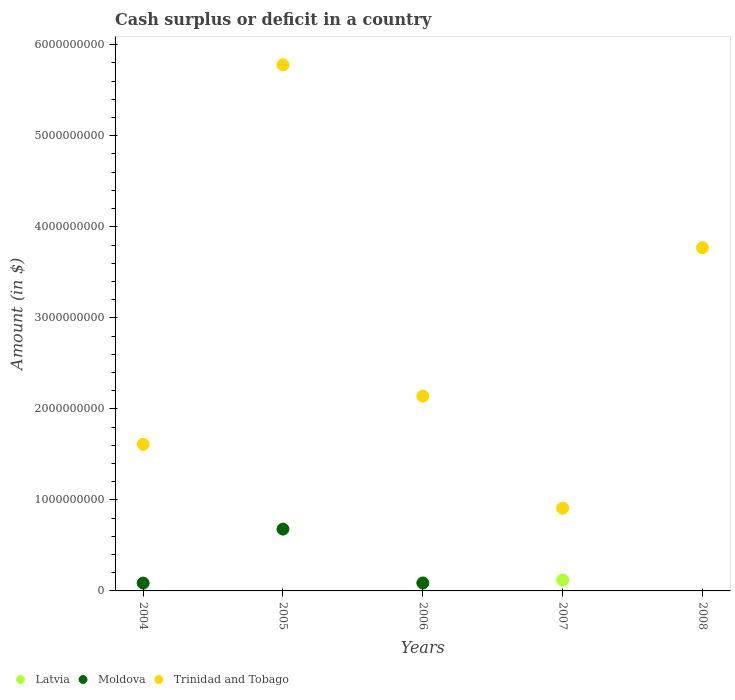How many different coloured dotlines are there?
Provide a succinct answer. 3. Is the number of dotlines equal to the number of legend labels?
Your response must be concise. No. Across all years, what is the maximum amount of cash surplus or deficit in Trinidad and Tobago?
Offer a very short reply. 5.78e+09. What is the total amount of cash surplus or deficit in Moldova in the graph?
Keep it short and to the point. 8.53e+08. What is the difference between the amount of cash surplus or deficit in Trinidad and Tobago in 2005 and that in 2007?
Provide a succinct answer. 4.87e+09. What is the difference between the amount of cash surplus or deficit in Latvia in 2004 and the amount of cash surplus or deficit in Trinidad and Tobago in 2005?
Make the answer very short. -5.78e+09. What is the average amount of cash surplus or deficit in Moldova per year?
Your answer should be very brief. 1.71e+08. In the year 2005, what is the difference between the amount of cash surplus or deficit in Trinidad and Tobago and amount of cash surplus or deficit in Moldova?
Make the answer very short. 5.10e+09. What is the ratio of the amount of cash surplus or deficit in Moldova in 2005 to that in 2006?
Provide a short and direct response. 7.76. Is the difference between the amount of cash surplus or deficit in Trinidad and Tobago in 2004 and 2005 greater than the difference between the amount of cash surplus or deficit in Moldova in 2004 and 2005?
Ensure brevity in your answer.  No. What is the difference between the highest and the second highest amount of cash surplus or deficit in Moldova?
Your answer should be compact. 5.92e+08. What is the difference between the highest and the lowest amount of cash surplus or deficit in Latvia?
Provide a short and direct response. 1.19e+08. In how many years, is the amount of cash surplus or deficit in Trinidad and Tobago greater than the average amount of cash surplus or deficit in Trinidad and Tobago taken over all years?
Give a very brief answer. 2. Is it the case that in every year, the sum of the amount of cash surplus or deficit in Trinidad and Tobago and amount of cash surplus or deficit in Moldova  is greater than the amount of cash surplus or deficit in Latvia?
Make the answer very short. Yes. Is the amount of cash surplus or deficit in Moldova strictly less than the amount of cash surplus or deficit in Latvia over the years?
Make the answer very short. No. How many dotlines are there?
Offer a very short reply. 3. Are the values on the major ticks of Y-axis written in scientific E-notation?
Provide a succinct answer. No. Where does the legend appear in the graph?
Make the answer very short. Bottom left. What is the title of the graph?
Your answer should be very brief. Cash surplus or deficit in a country. Does "Lesotho" appear as one of the legend labels in the graph?
Ensure brevity in your answer.  No. What is the label or title of the Y-axis?
Provide a succinct answer. Amount (in $). What is the Amount (in $) of Moldova in 2004?
Provide a short and direct response. 8.61e+07. What is the Amount (in $) in Trinidad and Tobago in 2004?
Ensure brevity in your answer.  1.61e+09. What is the Amount (in $) in Moldova in 2005?
Your answer should be very brief. 6.79e+08. What is the Amount (in $) of Trinidad and Tobago in 2005?
Keep it short and to the point. 5.78e+09. What is the Amount (in $) of Moldova in 2006?
Provide a succinct answer. 8.75e+07. What is the Amount (in $) in Trinidad and Tobago in 2006?
Your response must be concise. 2.14e+09. What is the Amount (in $) in Latvia in 2007?
Provide a short and direct response. 1.19e+08. What is the Amount (in $) of Moldova in 2007?
Keep it short and to the point. 0. What is the Amount (in $) in Trinidad and Tobago in 2007?
Your answer should be compact. 9.09e+08. What is the Amount (in $) of Moldova in 2008?
Your answer should be very brief. 0. What is the Amount (in $) of Trinidad and Tobago in 2008?
Make the answer very short. 3.77e+09. Across all years, what is the maximum Amount (in $) of Latvia?
Ensure brevity in your answer.  1.19e+08. Across all years, what is the maximum Amount (in $) in Moldova?
Make the answer very short. 6.79e+08. Across all years, what is the maximum Amount (in $) of Trinidad and Tobago?
Give a very brief answer. 5.78e+09. Across all years, what is the minimum Amount (in $) in Latvia?
Offer a terse response. 0. Across all years, what is the minimum Amount (in $) in Moldova?
Offer a very short reply. 0. Across all years, what is the minimum Amount (in $) in Trinidad and Tobago?
Offer a very short reply. 9.09e+08. What is the total Amount (in $) of Latvia in the graph?
Provide a short and direct response. 1.19e+08. What is the total Amount (in $) of Moldova in the graph?
Ensure brevity in your answer.  8.53e+08. What is the total Amount (in $) of Trinidad and Tobago in the graph?
Provide a short and direct response. 1.42e+1. What is the difference between the Amount (in $) of Moldova in 2004 and that in 2005?
Offer a terse response. -5.93e+08. What is the difference between the Amount (in $) of Trinidad and Tobago in 2004 and that in 2005?
Your response must be concise. -4.17e+09. What is the difference between the Amount (in $) of Moldova in 2004 and that in 2006?
Provide a short and direct response. -1.40e+06. What is the difference between the Amount (in $) of Trinidad and Tobago in 2004 and that in 2006?
Offer a terse response. -5.30e+08. What is the difference between the Amount (in $) of Trinidad and Tobago in 2004 and that in 2007?
Give a very brief answer. 7.01e+08. What is the difference between the Amount (in $) in Trinidad and Tobago in 2004 and that in 2008?
Your response must be concise. -2.16e+09. What is the difference between the Amount (in $) in Moldova in 2005 and that in 2006?
Give a very brief answer. 5.92e+08. What is the difference between the Amount (in $) in Trinidad and Tobago in 2005 and that in 2006?
Give a very brief answer. 3.64e+09. What is the difference between the Amount (in $) of Trinidad and Tobago in 2005 and that in 2007?
Your response must be concise. 4.87e+09. What is the difference between the Amount (in $) of Trinidad and Tobago in 2005 and that in 2008?
Offer a very short reply. 2.01e+09. What is the difference between the Amount (in $) of Trinidad and Tobago in 2006 and that in 2007?
Provide a succinct answer. 1.23e+09. What is the difference between the Amount (in $) in Trinidad and Tobago in 2006 and that in 2008?
Keep it short and to the point. -1.63e+09. What is the difference between the Amount (in $) in Trinidad and Tobago in 2007 and that in 2008?
Your response must be concise. -2.86e+09. What is the difference between the Amount (in $) in Moldova in 2004 and the Amount (in $) in Trinidad and Tobago in 2005?
Give a very brief answer. -5.69e+09. What is the difference between the Amount (in $) of Moldova in 2004 and the Amount (in $) of Trinidad and Tobago in 2006?
Offer a terse response. -2.05e+09. What is the difference between the Amount (in $) in Moldova in 2004 and the Amount (in $) in Trinidad and Tobago in 2007?
Your answer should be very brief. -8.23e+08. What is the difference between the Amount (in $) in Moldova in 2004 and the Amount (in $) in Trinidad and Tobago in 2008?
Your response must be concise. -3.68e+09. What is the difference between the Amount (in $) of Moldova in 2005 and the Amount (in $) of Trinidad and Tobago in 2006?
Your answer should be very brief. -1.46e+09. What is the difference between the Amount (in $) in Moldova in 2005 and the Amount (in $) in Trinidad and Tobago in 2007?
Provide a succinct answer. -2.30e+08. What is the difference between the Amount (in $) of Moldova in 2005 and the Amount (in $) of Trinidad and Tobago in 2008?
Provide a succinct answer. -3.09e+09. What is the difference between the Amount (in $) of Moldova in 2006 and the Amount (in $) of Trinidad and Tobago in 2007?
Your response must be concise. -8.22e+08. What is the difference between the Amount (in $) in Moldova in 2006 and the Amount (in $) in Trinidad and Tobago in 2008?
Offer a terse response. -3.68e+09. What is the difference between the Amount (in $) of Latvia in 2007 and the Amount (in $) of Trinidad and Tobago in 2008?
Your answer should be compact. -3.65e+09. What is the average Amount (in $) of Latvia per year?
Your response must be concise. 2.39e+07. What is the average Amount (in $) in Moldova per year?
Make the answer very short. 1.71e+08. What is the average Amount (in $) in Trinidad and Tobago per year?
Make the answer very short. 2.84e+09. In the year 2004, what is the difference between the Amount (in $) of Moldova and Amount (in $) of Trinidad and Tobago?
Your answer should be compact. -1.52e+09. In the year 2005, what is the difference between the Amount (in $) of Moldova and Amount (in $) of Trinidad and Tobago?
Your answer should be very brief. -5.10e+09. In the year 2006, what is the difference between the Amount (in $) of Moldova and Amount (in $) of Trinidad and Tobago?
Your answer should be very brief. -2.05e+09. In the year 2007, what is the difference between the Amount (in $) in Latvia and Amount (in $) in Trinidad and Tobago?
Offer a very short reply. -7.90e+08. What is the ratio of the Amount (in $) in Moldova in 2004 to that in 2005?
Ensure brevity in your answer.  0.13. What is the ratio of the Amount (in $) of Trinidad and Tobago in 2004 to that in 2005?
Your answer should be very brief. 0.28. What is the ratio of the Amount (in $) of Trinidad and Tobago in 2004 to that in 2006?
Offer a very short reply. 0.75. What is the ratio of the Amount (in $) of Trinidad and Tobago in 2004 to that in 2007?
Ensure brevity in your answer.  1.77. What is the ratio of the Amount (in $) in Trinidad and Tobago in 2004 to that in 2008?
Ensure brevity in your answer.  0.43. What is the ratio of the Amount (in $) of Moldova in 2005 to that in 2006?
Provide a succinct answer. 7.76. What is the ratio of the Amount (in $) in Trinidad and Tobago in 2005 to that in 2006?
Offer a very short reply. 2.7. What is the ratio of the Amount (in $) in Trinidad and Tobago in 2005 to that in 2007?
Your response must be concise. 6.36. What is the ratio of the Amount (in $) of Trinidad and Tobago in 2005 to that in 2008?
Provide a succinct answer. 1.53. What is the ratio of the Amount (in $) of Trinidad and Tobago in 2006 to that in 2007?
Give a very brief answer. 2.35. What is the ratio of the Amount (in $) in Trinidad and Tobago in 2006 to that in 2008?
Offer a terse response. 0.57. What is the ratio of the Amount (in $) in Trinidad and Tobago in 2007 to that in 2008?
Your answer should be very brief. 0.24. What is the difference between the highest and the second highest Amount (in $) in Moldova?
Your response must be concise. 5.92e+08. What is the difference between the highest and the second highest Amount (in $) in Trinidad and Tobago?
Make the answer very short. 2.01e+09. What is the difference between the highest and the lowest Amount (in $) in Latvia?
Provide a succinct answer. 1.19e+08. What is the difference between the highest and the lowest Amount (in $) in Moldova?
Your answer should be very brief. 6.79e+08. What is the difference between the highest and the lowest Amount (in $) of Trinidad and Tobago?
Offer a terse response. 4.87e+09. 